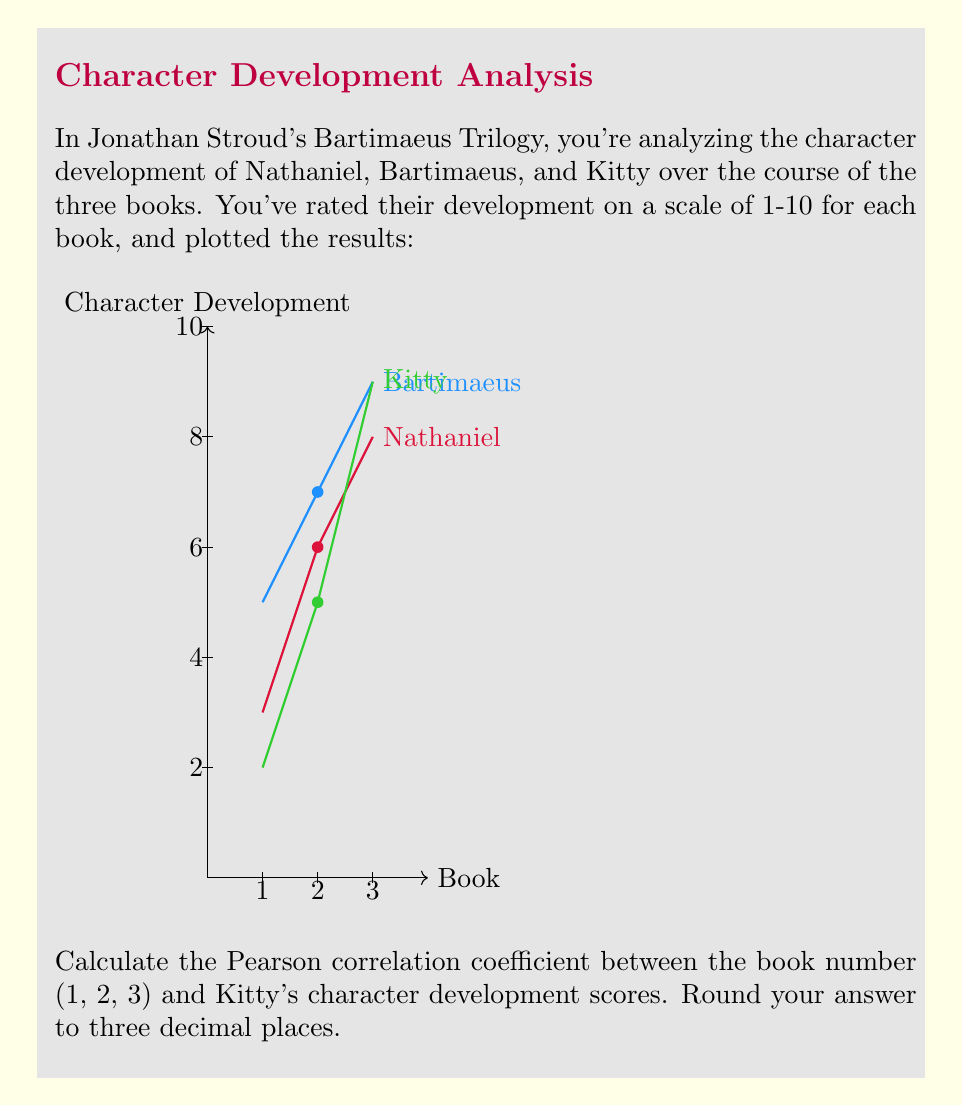Teach me how to tackle this problem. To calculate the Pearson correlation coefficient between the book number and Kitty's character development scores, we'll follow these steps:

1) Let $x$ be the book number and $y$ be Kitty's development score.

2) We have these data points:
   $(x_1, y_1) = (1, 2)$
   $(x_2, y_2) = (2, 5)$
   $(x_3, y_3) = (3, 9)$

3) The formula for Pearson correlation coefficient is:

   $$r = \frac{\sum_{i=1}^{n} (x_i - \bar{x})(y_i - \bar{y})}{\sqrt{\sum_{i=1}^{n} (x_i - \bar{x})^2} \sqrt{\sum_{i=1}^{n} (y_i - \bar{y})^2}}$$

4) First, calculate the means:
   $\bar{x} = \frac{1 + 2 + 3}{3} = 2$
   $\bar{y} = \frac{2 + 5 + 9}{3} = \frac{16}{3}$

5) Calculate $(x_i - \bar{x})$ and $(y_i - \bar{y})$ for each point:
   $(x_1 - \bar{x}) = 1 - 2 = -1$, $(y_1 - \bar{y}) = 2 - \frac{16}{3} = -\frac{10}{3}$
   $(x_2 - \bar{x}) = 2 - 2 = 0$,  $(y_2 - \bar{y}) = 5 - \frac{16}{3} = -\frac{1}{3}$
   $(x_3 - \bar{x}) = 3 - 2 = 1$,  $(y_3 - \bar{y}) = 9 - \frac{16}{3} = \frac{11}{3}$

6) Calculate the numerator:
   $\sum_{i=1}^{n} (x_i - \bar{x})(y_i - \bar{y}) = (-1)(-\frac{10}{3}) + (0)(-\frac{1}{3}) + (1)(\frac{11}{3}) = \frac{10}{3} + \frac{11}{3} = 7$

7) Calculate the denominator:
   $\sqrt{\sum_{i=1}^{n} (x_i - \bar{x})^2} = \sqrt{(-1)^2 + 0^2 + 1^2} = \sqrt{2}$
   $\sqrt{\sum_{i=1}^{n} (y_i - \bar{y})^2} = \sqrt{(-\frac{10}{3})^2 + (-\frac{1}{3})^2 + (\frac{11}{3})^2} = \sqrt{\frac{100}{9} + \frac{1}{9} + \frac{121}{9}} = \sqrt{\frac{222}{9}} = \frac{\sqrt{222}}{3}$

8) Now we can calculate $r$:
   $$r = \frac{7}{\sqrt{2} \cdot \frac{\sqrt{222}}{3}} = \frac{21}{\sqrt{444}} \approx 0.996$$

9) Rounding to three decimal places: 0.996
Answer: 0.996 